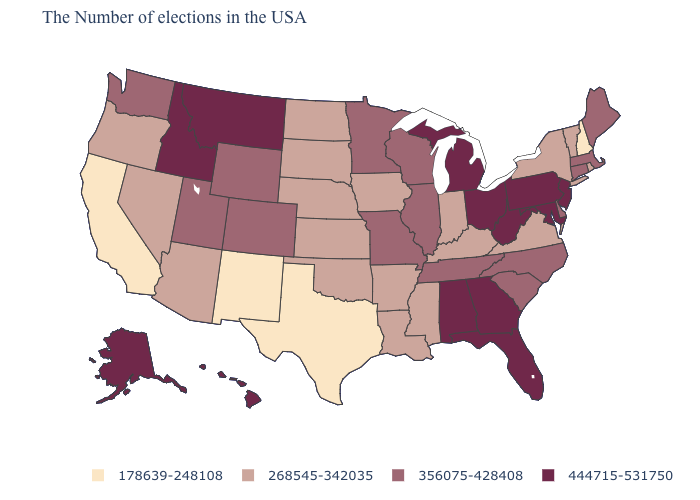How many symbols are there in the legend?
Write a very short answer. 4. Which states have the lowest value in the South?
Answer briefly. Texas. Name the states that have a value in the range 178639-248108?
Short answer required. New Hampshire, Texas, New Mexico, California. Name the states that have a value in the range 178639-248108?
Concise answer only. New Hampshire, Texas, New Mexico, California. Name the states that have a value in the range 356075-428408?
Short answer required. Maine, Massachusetts, Connecticut, Delaware, North Carolina, South Carolina, Tennessee, Wisconsin, Illinois, Missouri, Minnesota, Wyoming, Colorado, Utah, Washington. How many symbols are there in the legend?
Answer briefly. 4. Which states have the highest value in the USA?
Keep it brief. New Jersey, Maryland, Pennsylvania, West Virginia, Ohio, Florida, Georgia, Michigan, Alabama, Montana, Idaho, Alaska, Hawaii. Does the map have missing data?
Short answer required. No. Does Nebraska have the highest value in the USA?
Quick response, please. No. Name the states that have a value in the range 356075-428408?
Short answer required. Maine, Massachusetts, Connecticut, Delaware, North Carolina, South Carolina, Tennessee, Wisconsin, Illinois, Missouri, Minnesota, Wyoming, Colorado, Utah, Washington. What is the lowest value in the South?
Short answer required. 178639-248108. Does the first symbol in the legend represent the smallest category?
Short answer required. Yes. What is the value of Nevada?
Answer briefly. 268545-342035. How many symbols are there in the legend?
Be succinct. 4. What is the value of Wisconsin?
Concise answer only. 356075-428408. 